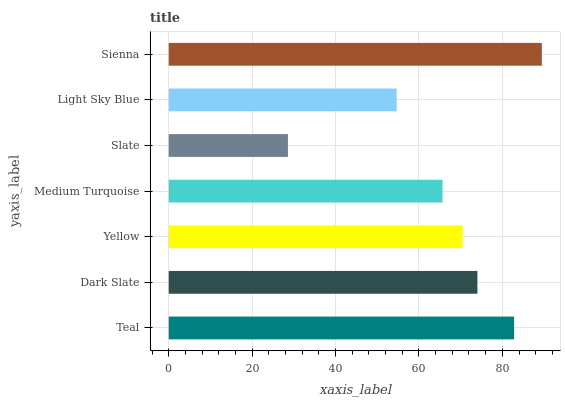Is Slate the minimum?
Answer yes or no. Yes. Is Sienna the maximum?
Answer yes or no. Yes. Is Dark Slate the minimum?
Answer yes or no. No. Is Dark Slate the maximum?
Answer yes or no. No. Is Teal greater than Dark Slate?
Answer yes or no. Yes. Is Dark Slate less than Teal?
Answer yes or no. Yes. Is Dark Slate greater than Teal?
Answer yes or no. No. Is Teal less than Dark Slate?
Answer yes or no. No. Is Yellow the high median?
Answer yes or no. Yes. Is Yellow the low median?
Answer yes or no. Yes. Is Slate the high median?
Answer yes or no. No. Is Light Sky Blue the low median?
Answer yes or no. No. 